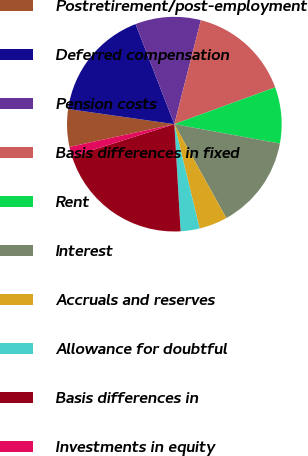Convert chart to OTSL. <chart><loc_0><loc_0><loc_500><loc_500><pie_chart><fcel>Postretirement/post-employment<fcel>Deferred compensation<fcel>Pension costs<fcel>Basis differences in fixed<fcel>Rent<fcel>Interest<fcel>Accruals and reserves<fcel>Allowance for doubtful<fcel>Basis differences in<fcel>Investments in equity<nl><fcel>5.66%<fcel>16.86%<fcel>9.86%<fcel>15.46%<fcel>8.46%<fcel>14.06%<fcel>4.26%<fcel>2.86%<fcel>21.05%<fcel>1.47%<nl></chart> 